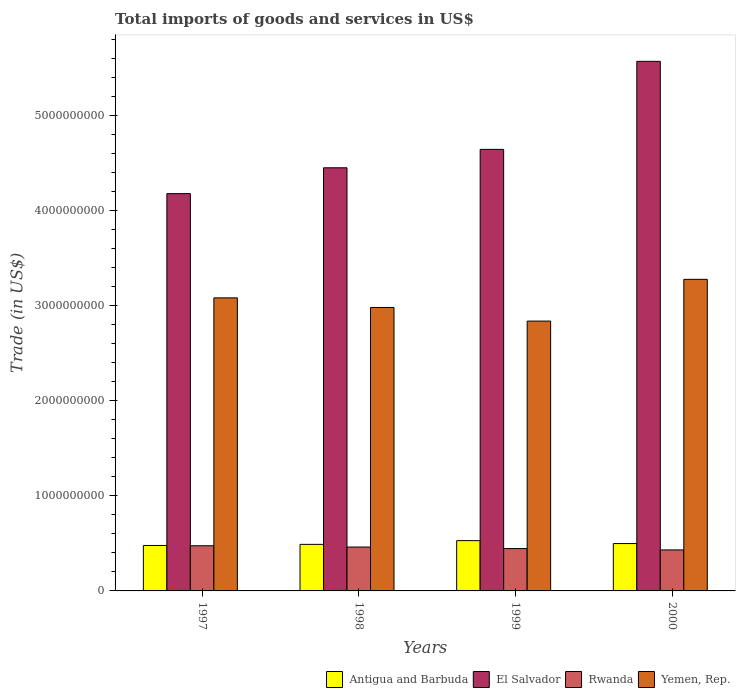Are the number of bars per tick equal to the number of legend labels?
Your answer should be compact. Yes. What is the total imports of goods and services in El Salvador in 1998?
Offer a terse response. 4.45e+09. Across all years, what is the maximum total imports of goods and services in Rwanda?
Your answer should be compact. 4.75e+08. Across all years, what is the minimum total imports of goods and services in Rwanda?
Offer a terse response. 4.32e+08. In which year was the total imports of goods and services in Rwanda maximum?
Offer a very short reply. 1997. In which year was the total imports of goods and services in Yemen, Rep. minimum?
Provide a short and direct response. 1999. What is the total total imports of goods and services in Yemen, Rep. in the graph?
Offer a very short reply. 1.22e+1. What is the difference between the total imports of goods and services in Antigua and Barbuda in 1997 and that in 1998?
Offer a terse response. -1.16e+07. What is the difference between the total imports of goods and services in Rwanda in 1998 and the total imports of goods and services in El Salvador in 1999?
Ensure brevity in your answer.  -4.19e+09. What is the average total imports of goods and services in Yemen, Rep. per year?
Provide a short and direct response. 3.05e+09. In the year 1998, what is the difference between the total imports of goods and services in El Salvador and total imports of goods and services in Rwanda?
Provide a short and direct response. 3.99e+09. In how many years, is the total imports of goods and services in El Salvador greater than 4400000000 US$?
Make the answer very short. 3. What is the ratio of the total imports of goods and services in El Salvador in 1997 to that in 2000?
Offer a very short reply. 0.75. Is the total imports of goods and services in Antigua and Barbuda in 1997 less than that in 1998?
Give a very brief answer. Yes. What is the difference between the highest and the second highest total imports of goods and services in Antigua and Barbuda?
Make the answer very short. 3.09e+07. What is the difference between the highest and the lowest total imports of goods and services in El Salvador?
Your answer should be compact. 1.39e+09. In how many years, is the total imports of goods and services in Rwanda greater than the average total imports of goods and services in Rwanda taken over all years?
Keep it short and to the point. 2. Is the sum of the total imports of goods and services in Rwanda in 1997 and 2000 greater than the maximum total imports of goods and services in El Salvador across all years?
Keep it short and to the point. No. Is it the case that in every year, the sum of the total imports of goods and services in Antigua and Barbuda and total imports of goods and services in El Salvador is greater than the sum of total imports of goods and services in Rwanda and total imports of goods and services in Yemen, Rep.?
Your answer should be very brief. Yes. What does the 3rd bar from the left in 1999 represents?
Provide a short and direct response. Rwanda. What does the 4th bar from the right in 1999 represents?
Your response must be concise. Antigua and Barbuda. Is it the case that in every year, the sum of the total imports of goods and services in Yemen, Rep. and total imports of goods and services in Antigua and Barbuda is greater than the total imports of goods and services in El Salvador?
Offer a terse response. No. How many bars are there?
Offer a terse response. 16. Are all the bars in the graph horizontal?
Ensure brevity in your answer.  No. How many years are there in the graph?
Give a very brief answer. 4. What is the difference between two consecutive major ticks on the Y-axis?
Your answer should be compact. 1.00e+09. Are the values on the major ticks of Y-axis written in scientific E-notation?
Provide a short and direct response. No. Does the graph contain any zero values?
Ensure brevity in your answer.  No. Does the graph contain grids?
Provide a succinct answer. No. Where does the legend appear in the graph?
Your response must be concise. Bottom right. How many legend labels are there?
Provide a succinct answer. 4. How are the legend labels stacked?
Offer a terse response. Horizontal. What is the title of the graph?
Offer a terse response. Total imports of goods and services in US$. What is the label or title of the X-axis?
Provide a short and direct response. Years. What is the label or title of the Y-axis?
Provide a short and direct response. Trade (in US$). What is the Trade (in US$) in Antigua and Barbuda in 1997?
Make the answer very short. 4.78e+08. What is the Trade (in US$) of El Salvador in 1997?
Your response must be concise. 4.18e+09. What is the Trade (in US$) in Rwanda in 1997?
Your answer should be compact. 4.75e+08. What is the Trade (in US$) of Yemen, Rep. in 1997?
Give a very brief answer. 3.08e+09. What is the Trade (in US$) of Antigua and Barbuda in 1998?
Give a very brief answer. 4.90e+08. What is the Trade (in US$) of El Salvador in 1998?
Your answer should be compact. 4.45e+09. What is the Trade (in US$) in Rwanda in 1998?
Give a very brief answer. 4.62e+08. What is the Trade (in US$) of Yemen, Rep. in 1998?
Provide a succinct answer. 2.98e+09. What is the Trade (in US$) in Antigua and Barbuda in 1999?
Provide a short and direct response. 5.29e+08. What is the Trade (in US$) in El Salvador in 1999?
Offer a very short reply. 4.65e+09. What is the Trade (in US$) of Rwanda in 1999?
Provide a succinct answer. 4.46e+08. What is the Trade (in US$) in Yemen, Rep. in 1999?
Your answer should be very brief. 2.84e+09. What is the Trade (in US$) of Antigua and Barbuda in 2000?
Ensure brevity in your answer.  4.98e+08. What is the Trade (in US$) of El Salvador in 2000?
Offer a terse response. 5.57e+09. What is the Trade (in US$) in Rwanda in 2000?
Keep it short and to the point. 4.32e+08. What is the Trade (in US$) of Yemen, Rep. in 2000?
Ensure brevity in your answer.  3.28e+09. Across all years, what is the maximum Trade (in US$) in Antigua and Barbuda?
Your answer should be compact. 5.29e+08. Across all years, what is the maximum Trade (in US$) of El Salvador?
Provide a short and direct response. 5.57e+09. Across all years, what is the maximum Trade (in US$) in Rwanda?
Provide a succinct answer. 4.75e+08. Across all years, what is the maximum Trade (in US$) of Yemen, Rep.?
Offer a terse response. 3.28e+09. Across all years, what is the minimum Trade (in US$) in Antigua and Barbuda?
Keep it short and to the point. 4.78e+08. Across all years, what is the minimum Trade (in US$) in El Salvador?
Offer a terse response. 4.18e+09. Across all years, what is the minimum Trade (in US$) in Rwanda?
Offer a very short reply. 4.32e+08. Across all years, what is the minimum Trade (in US$) in Yemen, Rep.?
Make the answer very short. 2.84e+09. What is the total Trade (in US$) in Antigua and Barbuda in the graph?
Provide a succinct answer. 2.00e+09. What is the total Trade (in US$) in El Salvador in the graph?
Provide a short and direct response. 1.89e+1. What is the total Trade (in US$) in Rwanda in the graph?
Your answer should be compact. 1.81e+09. What is the total Trade (in US$) in Yemen, Rep. in the graph?
Ensure brevity in your answer.  1.22e+1. What is the difference between the Trade (in US$) in Antigua and Barbuda in 1997 and that in 1998?
Provide a short and direct response. -1.16e+07. What is the difference between the Trade (in US$) in El Salvador in 1997 and that in 1998?
Make the answer very short. -2.72e+08. What is the difference between the Trade (in US$) in Rwanda in 1997 and that in 1998?
Keep it short and to the point. 1.36e+07. What is the difference between the Trade (in US$) in Yemen, Rep. in 1997 and that in 1998?
Provide a short and direct response. 1.01e+08. What is the difference between the Trade (in US$) in Antigua and Barbuda in 1997 and that in 1999?
Keep it short and to the point. -5.10e+07. What is the difference between the Trade (in US$) of El Salvador in 1997 and that in 1999?
Provide a short and direct response. -4.66e+08. What is the difference between the Trade (in US$) of Rwanda in 1997 and that in 1999?
Your answer should be very brief. 2.95e+07. What is the difference between the Trade (in US$) of Yemen, Rep. in 1997 and that in 1999?
Your answer should be compact. 2.44e+08. What is the difference between the Trade (in US$) of Antigua and Barbuda in 1997 and that in 2000?
Provide a short and direct response. -2.02e+07. What is the difference between the Trade (in US$) of El Salvador in 1997 and that in 2000?
Your answer should be compact. -1.39e+09. What is the difference between the Trade (in US$) in Rwanda in 1997 and that in 2000?
Give a very brief answer. 4.37e+07. What is the difference between the Trade (in US$) in Yemen, Rep. in 1997 and that in 2000?
Offer a very short reply. -1.95e+08. What is the difference between the Trade (in US$) in Antigua and Barbuda in 1998 and that in 1999?
Ensure brevity in your answer.  -3.94e+07. What is the difference between the Trade (in US$) in El Salvador in 1998 and that in 1999?
Ensure brevity in your answer.  -1.94e+08. What is the difference between the Trade (in US$) in Rwanda in 1998 and that in 1999?
Provide a short and direct response. 1.59e+07. What is the difference between the Trade (in US$) of Yemen, Rep. in 1998 and that in 1999?
Ensure brevity in your answer.  1.43e+08. What is the difference between the Trade (in US$) in Antigua and Barbuda in 1998 and that in 2000?
Provide a succinct answer. -8.54e+06. What is the difference between the Trade (in US$) of El Salvador in 1998 and that in 2000?
Offer a very short reply. -1.12e+09. What is the difference between the Trade (in US$) of Rwanda in 1998 and that in 2000?
Keep it short and to the point. 3.01e+07. What is the difference between the Trade (in US$) in Yemen, Rep. in 1998 and that in 2000?
Offer a terse response. -2.96e+08. What is the difference between the Trade (in US$) in Antigua and Barbuda in 1999 and that in 2000?
Keep it short and to the point. 3.09e+07. What is the difference between the Trade (in US$) in El Salvador in 1999 and that in 2000?
Your response must be concise. -9.26e+08. What is the difference between the Trade (in US$) in Rwanda in 1999 and that in 2000?
Offer a very short reply. 1.42e+07. What is the difference between the Trade (in US$) in Yemen, Rep. in 1999 and that in 2000?
Make the answer very short. -4.39e+08. What is the difference between the Trade (in US$) in Antigua and Barbuda in 1997 and the Trade (in US$) in El Salvador in 1998?
Ensure brevity in your answer.  -3.97e+09. What is the difference between the Trade (in US$) in Antigua and Barbuda in 1997 and the Trade (in US$) in Rwanda in 1998?
Keep it short and to the point. 1.66e+07. What is the difference between the Trade (in US$) of Antigua and Barbuda in 1997 and the Trade (in US$) of Yemen, Rep. in 1998?
Provide a succinct answer. -2.50e+09. What is the difference between the Trade (in US$) in El Salvador in 1997 and the Trade (in US$) in Rwanda in 1998?
Offer a very short reply. 3.72e+09. What is the difference between the Trade (in US$) in El Salvador in 1997 and the Trade (in US$) in Yemen, Rep. in 1998?
Make the answer very short. 1.20e+09. What is the difference between the Trade (in US$) in Rwanda in 1997 and the Trade (in US$) in Yemen, Rep. in 1998?
Ensure brevity in your answer.  -2.51e+09. What is the difference between the Trade (in US$) of Antigua and Barbuda in 1997 and the Trade (in US$) of El Salvador in 1999?
Keep it short and to the point. -4.17e+09. What is the difference between the Trade (in US$) of Antigua and Barbuda in 1997 and the Trade (in US$) of Rwanda in 1999?
Provide a short and direct response. 3.25e+07. What is the difference between the Trade (in US$) in Antigua and Barbuda in 1997 and the Trade (in US$) in Yemen, Rep. in 1999?
Your answer should be compact. -2.36e+09. What is the difference between the Trade (in US$) of El Salvador in 1997 and the Trade (in US$) of Rwanda in 1999?
Your answer should be very brief. 3.74e+09. What is the difference between the Trade (in US$) of El Salvador in 1997 and the Trade (in US$) of Yemen, Rep. in 1999?
Offer a terse response. 1.34e+09. What is the difference between the Trade (in US$) in Rwanda in 1997 and the Trade (in US$) in Yemen, Rep. in 1999?
Provide a succinct answer. -2.36e+09. What is the difference between the Trade (in US$) of Antigua and Barbuda in 1997 and the Trade (in US$) of El Salvador in 2000?
Keep it short and to the point. -5.10e+09. What is the difference between the Trade (in US$) in Antigua and Barbuda in 1997 and the Trade (in US$) in Rwanda in 2000?
Your answer should be very brief. 4.67e+07. What is the difference between the Trade (in US$) in Antigua and Barbuda in 1997 and the Trade (in US$) in Yemen, Rep. in 2000?
Your answer should be very brief. -2.80e+09. What is the difference between the Trade (in US$) in El Salvador in 1997 and the Trade (in US$) in Rwanda in 2000?
Your answer should be very brief. 3.75e+09. What is the difference between the Trade (in US$) of El Salvador in 1997 and the Trade (in US$) of Yemen, Rep. in 2000?
Your answer should be very brief. 9.02e+08. What is the difference between the Trade (in US$) in Rwanda in 1997 and the Trade (in US$) in Yemen, Rep. in 2000?
Provide a succinct answer. -2.80e+09. What is the difference between the Trade (in US$) in Antigua and Barbuda in 1998 and the Trade (in US$) in El Salvador in 1999?
Give a very brief answer. -4.16e+09. What is the difference between the Trade (in US$) of Antigua and Barbuda in 1998 and the Trade (in US$) of Rwanda in 1999?
Your answer should be compact. 4.41e+07. What is the difference between the Trade (in US$) of Antigua and Barbuda in 1998 and the Trade (in US$) of Yemen, Rep. in 1999?
Your answer should be very brief. -2.35e+09. What is the difference between the Trade (in US$) of El Salvador in 1998 and the Trade (in US$) of Rwanda in 1999?
Your response must be concise. 4.01e+09. What is the difference between the Trade (in US$) of El Salvador in 1998 and the Trade (in US$) of Yemen, Rep. in 1999?
Provide a short and direct response. 1.61e+09. What is the difference between the Trade (in US$) of Rwanda in 1998 and the Trade (in US$) of Yemen, Rep. in 1999?
Your response must be concise. -2.38e+09. What is the difference between the Trade (in US$) in Antigua and Barbuda in 1998 and the Trade (in US$) in El Salvador in 2000?
Offer a very short reply. -5.08e+09. What is the difference between the Trade (in US$) of Antigua and Barbuda in 1998 and the Trade (in US$) of Rwanda in 2000?
Ensure brevity in your answer.  5.83e+07. What is the difference between the Trade (in US$) in Antigua and Barbuda in 1998 and the Trade (in US$) in Yemen, Rep. in 2000?
Give a very brief answer. -2.79e+09. What is the difference between the Trade (in US$) in El Salvador in 1998 and the Trade (in US$) in Rwanda in 2000?
Give a very brief answer. 4.02e+09. What is the difference between the Trade (in US$) of El Salvador in 1998 and the Trade (in US$) of Yemen, Rep. in 2000?
Make the answer very short. 1.17e+09. What is the difference between the Trade (in US$) in Rwanda in 1998 and the Trade (in US$) in Yemen, Rep. in 2000?
Your response must be concise. -2.82e+09. What is the difference between the Trade (in US$) of Antigua and Barbuda in 1999 and the Trade (in US$) of El Salvador in 2000?
Provide a short and direct response. -5.04e+09. What is the difference between the Trade (in US$) of Antigua and Barbuda in 1999 and the Trade (in US$) of Rwanda in 2000?
Provide a short and direct response. 9.77e+07. What is the difference between the Trade (in US$) in Antigua and Barbuda in 1999 and the Trade (in US$) in Yemen, Rep. in 2000?
Provide a succinct answer. -2.75e+09. What is the difference between the Trade (in US$) in El Salvador in 1999 and the Trade (in US$) in Rwanda in 2000?
Your response must be concise. 4.22e+09. What is the difference between the Trade (in US$) in El Salvador in 1999 and the Trade (in US$) in Yemen, Rep. in 2000?
Your response must be concise. 1.37e+09. What is the difference between the Trade (in US$) of Rwanda in 1999 and the Trade (in US$) of Yemen, Rep. in 2000?
Make the answer very short. -2.83e+09. What is the average Trade (in US$) of Antigua and Barbuda per year?
Keep it short and to the point. 4.99e+08. What is the average Trade (in US$) of El Salvador per year?
Your answer should be very brief. 4.71e+09. What is the average Trade (in US$) in Rwanda per year?
Provide a succinct answer. 4.54e+08. What is the average Trade (in US$) of Yemen, Rep. per year?
Offer a very short reply. 3.05e+09. In the year 1997, what is the difference between the Trade (in US$) in Antigua and Barbuda and Trade (in US$) in El Salvador?
Provide a short and direct response. -3.70e+09. In the year 1997, what is the difference between the Trade (in US$) of Antigua and Barbuda and Trade (in US$) of Rwanda?
Keep it short and to the point. 2.99e+06. In the year 1997, what is the difference between the Trade (in US$) of Antigua and Barbuda and Trade (in US$) of Yemen, Rep.?
Keep it short and to the point. -2.61e+09. In the year 1997, what is the difference between the Trade (in US$) of El Salvador and Trade (in US$) of Rwanda?
Provide a succinct answer. 3.71e+09. In the year 1997, what is the difference between the Trade (in US$) of El Salvador and Trade (in US$) of Yemen, Rep.?
Make the answer very short. 1.10e+09. In the year 1997, what is the difference between the Trade (in US$) in Rwanda and Trade (in US$) in Yemen, Rep.?
Offer a very short reply. -2.61e+09. In the year 1998, what is the difference between the Trade (in US$) in Antigua and Barbuda and Trade (in US$) in El Salvador?
Ensure brevity in your answer.  -3.96e+09. In the year 1998, what is the difference between the Trade (in US$) in Antigua and Barbuda and Trade (in US$) in Rwanda?
Make the answer very short. 2.82e+07. In the year 1998, what is the difference between the Trade (in US$) in Antigua and Barbuda and Trade (in US$) in Yemen, Rep.?
Provide a succinct answer. -2.49e+09. In the year 1998, what is the difference between the Trade (in US$) in El Salvador and Trade (in US$) in Rwanda?
Ensure brevity in your answer.  3.99e+09. In the year 1998, what is the difference between the Trade (in US$) in El Salvador and Trade (in US$) in Yemen, Rep.?
Your response must be concise. 1.47e+09. In the year 1998, what is the difference between the Trade (in US$) of Rwanda and Trade (in US$) of Yemen, Rep.?
Keep it short and to the point. -2.52e+09. In the year 1999, what is the difference between the Trade (in US$) in Antigua and Barbuda and Trade (in US$) in El Salvador?
Keep it short and to the point. -4.12e+09. In the year 1999, what is the difference between the Trade (in US$) in Antigua and Barbuda and Trade (in US$) in Rwanda?
Provide a succinct answer. 8.35e+07. In the year 1999, what is the difference between the Trade (in US$) of Antigua and Barbuda and Trade (in US$) of Yemen, Rep.?
Offer a terse response. -2.31e+09. In the year 1999, what is the difference between the Trade (in US$) of El Salvador and Trade (in US$) of Rwanda?
Ensure brevity in your answer.  4.20e+09. In the year 1999, what is the difference between the Trade (in US$) of El Salvador and Trade (in US$) of Yemen, Rep.?
Make the answer very short. 1.81e+09. In the year 1999, what is the difference between the Trade (in US$) in Rwanda and Trade (in US$) in Yemen, Rep.?
Your answer should be compact. -2.39e+09. In the year 2000, what is the difference between the Trade (in US$) of Antigua and Barbuda and Trade (in US$) of El Salvador?
Make the answer very short. -5.07e+09. In the year 2000, what is the difference between the Trade (in US$) of Antigua and Barbuda and Trade (in US$) of Rwanda?
Give a very brief answer. 6.68e+07. In the year 2000, what is the difference between the Trade (in US$) of Antigua and Barbuda and Trade (in US$) of Yemen, Rep.?
Make the answer very short. -2.78e+09. In the year 2000, what is the difference between the Trade (in US$) in El Salvador and Trade (in US$) in Rwanda?
Your response must be concise. 5.14e+09. In the year 2000, what is the difference between the Trade (in US$) in El Salvador and Trade (in US$) in Yemen, Rep.?
Provide a succinct answer. 2.29e+09. In the year 2000, what is the difference between the Trade (in US$) in Rwanda and Trade (in US$) in Yemen, Rep.?
Ensure brevity in your answer.  -2.85e+09. What is the ratio of the Trade (in US$) of Antigua and Barbuda in 1997 to that in 1998?
Offer a terse response. 0.98. What is the ratio of the Trade (in US$) of El Salvador in 1997 to that in 1998?
Provide a short and direct response. 0.94. What is the ratio of the Trade (in US$) in Rwanda in 1997 to that in 1998?
Provide a succinct answer. 1.03. What is the ratio of the Trade (in US$) in Yemen, Rep. in 1997 to that in 1998?
Your response must be concise. 1.03. What is the ratio of the Trade (in US$) of Antigua and Barbuda in 1997 to that in 1999?
Your response must be concise. 0.9. What is the ratio of the Trade (in US$) in El Salvador in 1997 to that in 1999?
Make the answer very short. 0.9. What is the ratio of the Trade (in US$) of Rwanda in 1997 to that in 1999?
Your answer should be compact. 1.07. What is the ratio of the Trade (in US$) of Yemen, Rep. in 1997 to that in 1999?
Keep it short and to the point. 1.09. What is the ratio of the Trade (in US$) in Antigua and Barbuda in 1997 to that in 2000?
Offer a very short reply. 0.96. What is the ratio of the Trade (in US$) in El Salvador in 1997 to that in 2000?
Offer a very short reply. 0.75. What is the ratio of the Trade (in US$) in Rwanda in 1997 to that in 2000?
Offer a very short reply. 1.1. What is the ratio of the Trade (in US$) in Yemen, Rep. in 1997 to that in 2000?
Provide a short and direct response. 0.94. What is the ratio of the Trade (in US$) in Antigua and Barbuda in 1998 to that in 1999?
Ensure brevity in your answer.  0.93. What is the ratio of the Trade (in US$) in Rwanda in 1998 to that in 1999?
Keep it short and to the point. 1.04. What is the ratio of the Trade (in US$) in Yemen, Rep. in 1998 to that in 1999?
Offer a very short reply. 1.05. What is the ratio of the Trade (in US$) of Antigua and Barbuda in 1998 to that in 2000?
Offer a terse response. 0.98. What is the ratio of the Trade (in US$) of El Salvador in 1998 to that in 2000?
Your response must be concise. 0.8. What is the ratio of the Trade (in US$) in Rwanda in 1998 to that in 2000?
Your answer should be compact. 1.07. What is the ratio of the Trade (in US$) of Yemen, Rep. in 1998 to that in 2000?
Your response must be concise. 0.91. What is the ratio of the Trade (in US$) of Antigua and Barbuda in 1999 to that in 2000?
Your answer should be very brief. 1.06. What is the ratio of the Trade (in US$) of El Salvador in 1999 to that in 2000?
Provide a short and direct response. 0.83. What is the ratio of the Trade (in US$) in Rwanda in 1999 to that in 2000?
Your response must be concise. 1.03. What is the ratio of the Trade (in US$) in Yemen, Rep. in 1999 to that in 2000?
Provide a short and direct response. 0.87. What is the difference between the highest and the second highest Trade (in US$) in Antigua and Barbuda?
Your response must be concise. 3.09e+07. What is the difference between the highest and the second highest Trade (in US$) in El Salvador?
Your answer should be compact. 9.26e+08. What is the difference between the highest and the second highest Trade (in US$) in Rwanda?
Offer a terse response. 1.36e+07. What is the difference between the highest and the second highest Trade (in US$) in Yemen, Rep.?
Offer a very short reply. 1.95e+08. What is the difference between the highest and the lowest Trade (in US$) of Antigua and Barbuda?
Provide a succinct answer. 5.10e+07. What is the difference between the highest and the lowest Trade (in US$) in El Salvador?
Provide a short and direct response. 1.39e+09. What is the difference between the highest and the lowest Trade (in US$) of Rwanda?
Your answer should be very brief. 4.37e+07. What is the difference between the highest and the lowest Trade (in US$) in Yemen, Rep.?
Provide a short and direct response. 4.39e+08. 